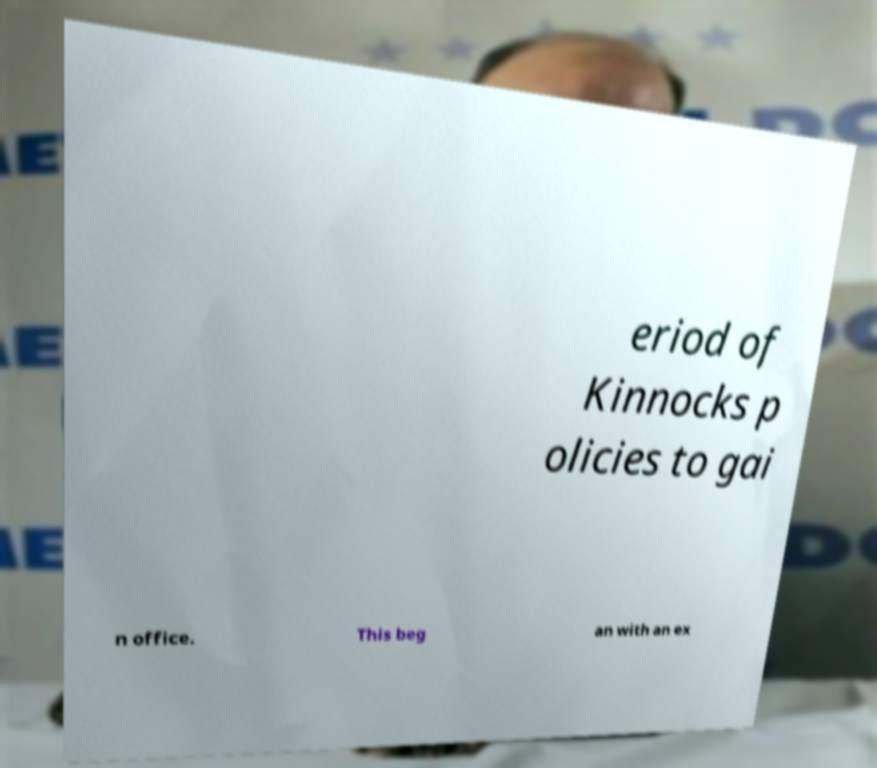Please identify and transcribe the text found in this image. eriod of Kinnocks p olicies to gai n office. This beg an with an ex 